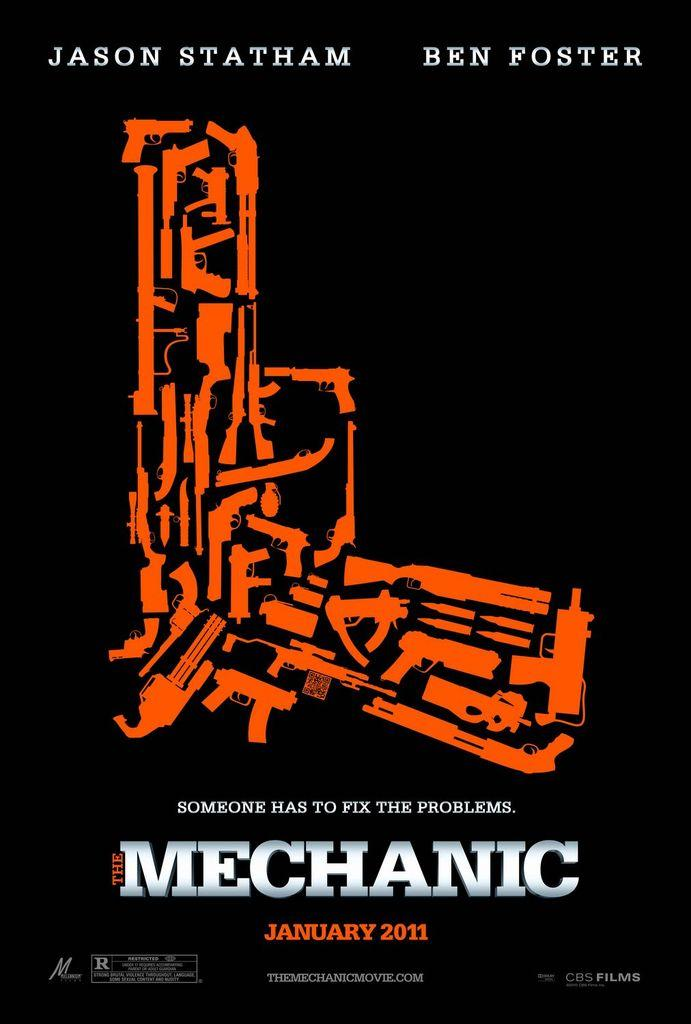Provide a one-sentence caption for the provided image. A movie poster about The Mechanic with an abstract orange gun photo in the center and the names Jason Statham and Ben Foster above. 